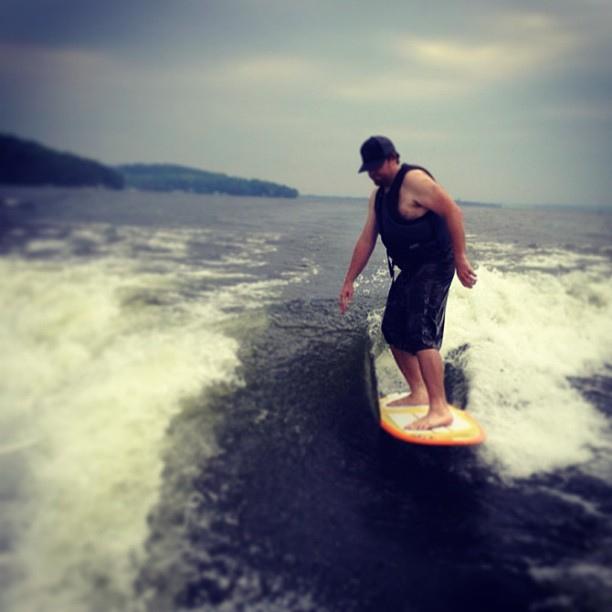What is this man doing?
Quick response, please. Surfing. Where does he have his right hand?
Short answer required. Nothing. Is the weather sunny?
Give a very brief answer. No. Is it a cold day?
Write a very short answer. No. What is the person wearing?
Be succinct. Life jacket. Is he having fun?
Keep it brief. Yes. What is under the man?
Concise answer only. Surfboard. What is the man wearing?
Concise answer only. Life vest. 